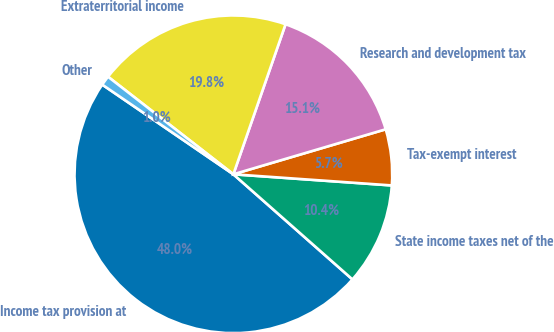Convert chart to OTSL. <chart><loc_0><loc_0><loc_500><loc_500><pie_chart><fcel>Income tax provision at<fcel>State income taxes net of the<fcel>Tax-exempt interest<fcel>Research and development tax<fcel>Extraterritorial income<fcel>Other<nl><fcel>48.03%<fcel>10.39%<fcel>5.69%<fcel>15.1%<fcel>19.8%<fcel>0.98%<nl></chart> 